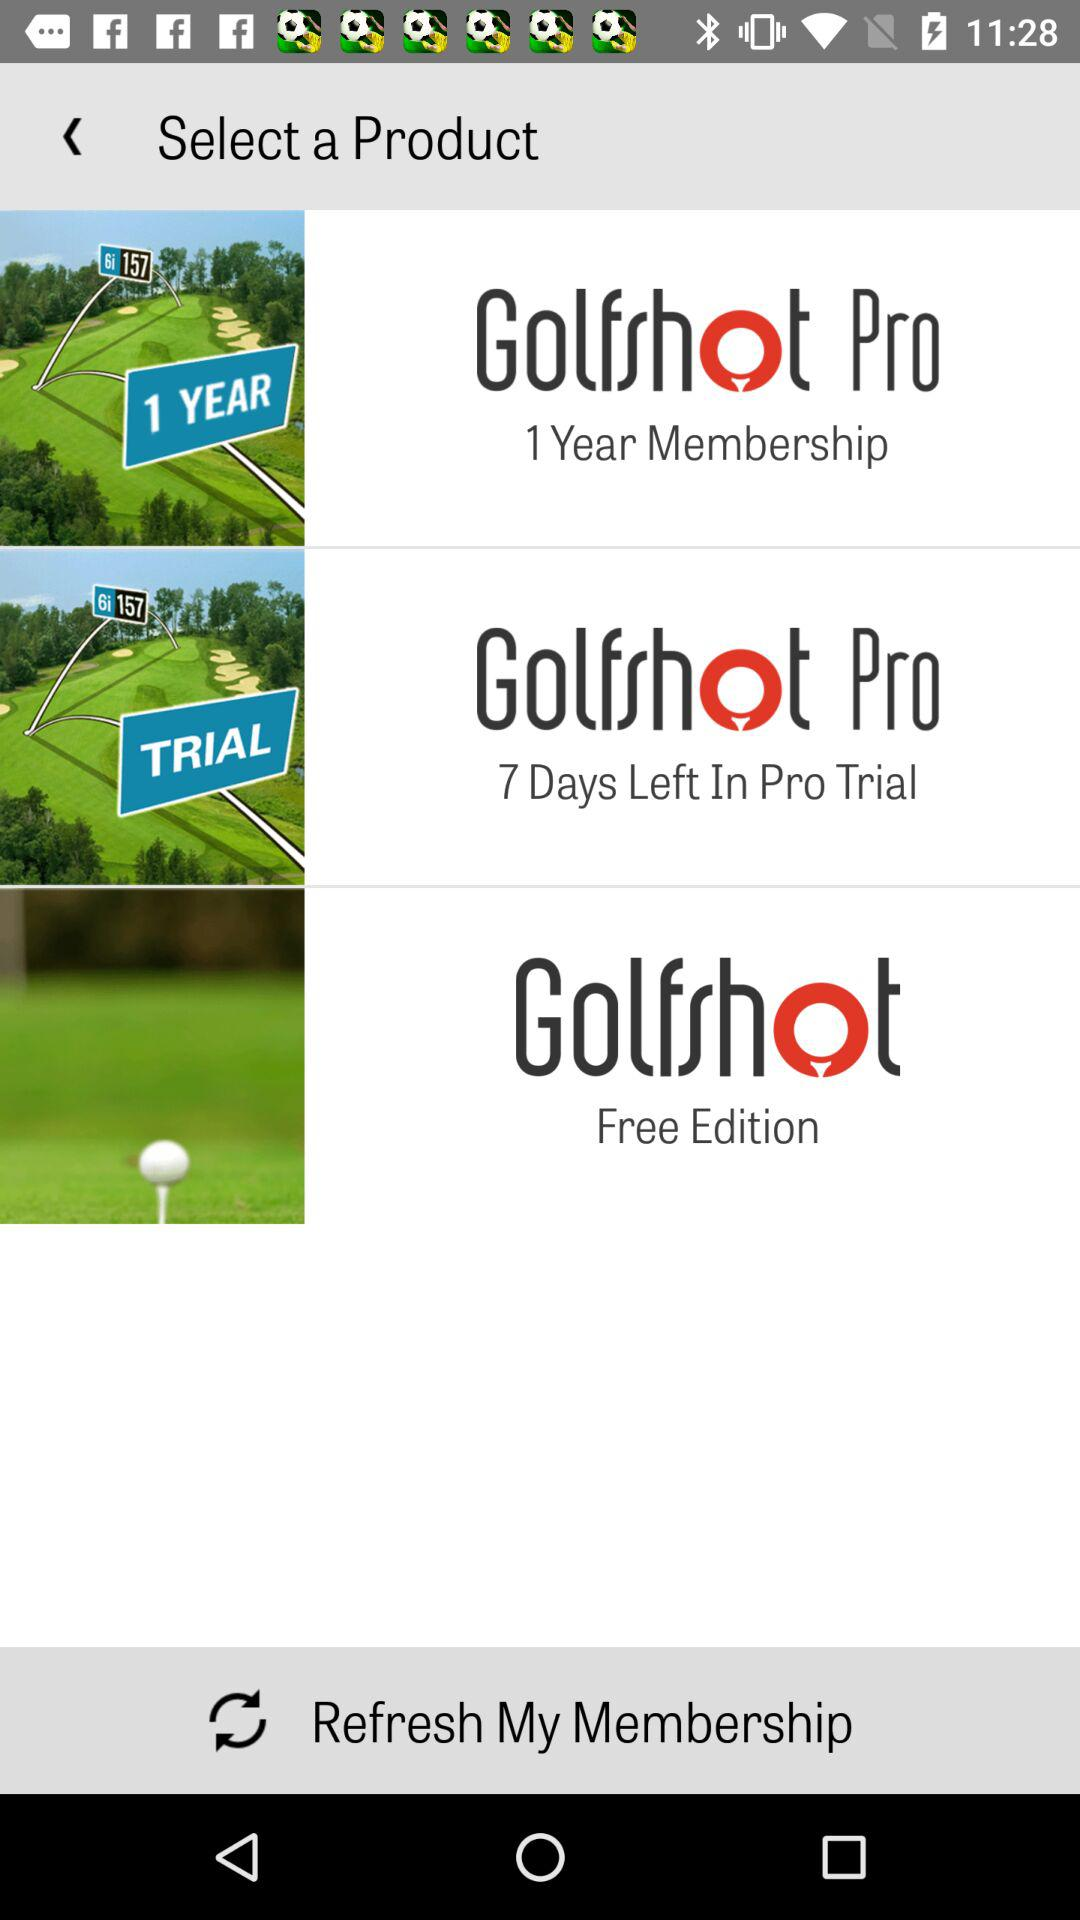How many products are available?
Answer the question using a single word or phrase. 3 